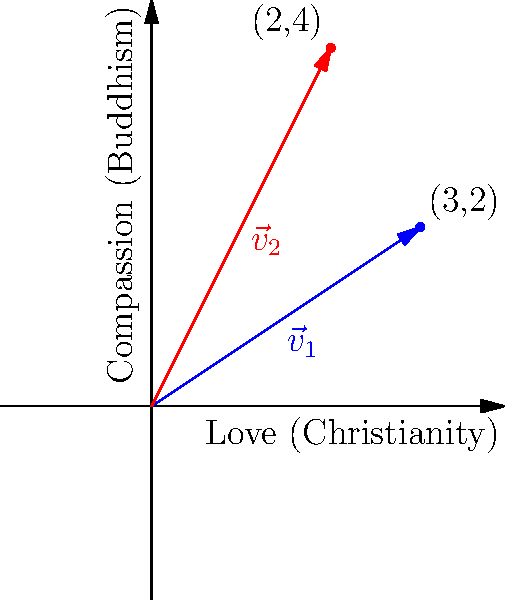Consider two vectors representing key virtues in Christianity and Buddhism: $\vec{v}_1 = (3,2)$ for Love (Christianity) and $\vec{v}_2 = (2,4)$ for Compassion (Buddhism). Calculate the dot product of these vectors and interpret its meaning in the context of interfaith dialogue. To solve this problem, we'll follow these steps:

1) Recall the formula for the dot product of two vectors:
   $\vec{a} \cdot \vec{b} = a_x b_x + a_y b_y$

2) Substitute the given values:
   $\vec{v}_1 = (3,2)$ and $\vec{v}_2 = (2,4)$

3) Calculate the dot product:
   $\vec{v}_1 \cdot \vec{v}_2 = (3 \times 2) + (2 \times 4)$
   $\vec{v}_1 \cdot \vec{v}_2 = 6 + 8 = 14$

4) Interpret the result:
   The positive dot product (14) indicates that these virtues are aligned and complementary. In the context of interfaith dialogue, this suggests that Love in Christianity and Compassion in Buddhism are harmonious concepts that point in similar spiritual directions.

5) The magnitude of the dot product (14) is relatively large, considering the vector components. This implies a strong correlation between these virtues, highlighting significant common ground between Christianity and Buddhism in their emphasis on Love and Compassion.

6) This mathematical representation can be used to illustrate how core values from different faith traditions can be compared and found to be mutually reinforcing, promoting understanding and respect in interfaith discussions.
Answer: 14; indicates strong alignment between Christian Love and Buddhist Compassion 